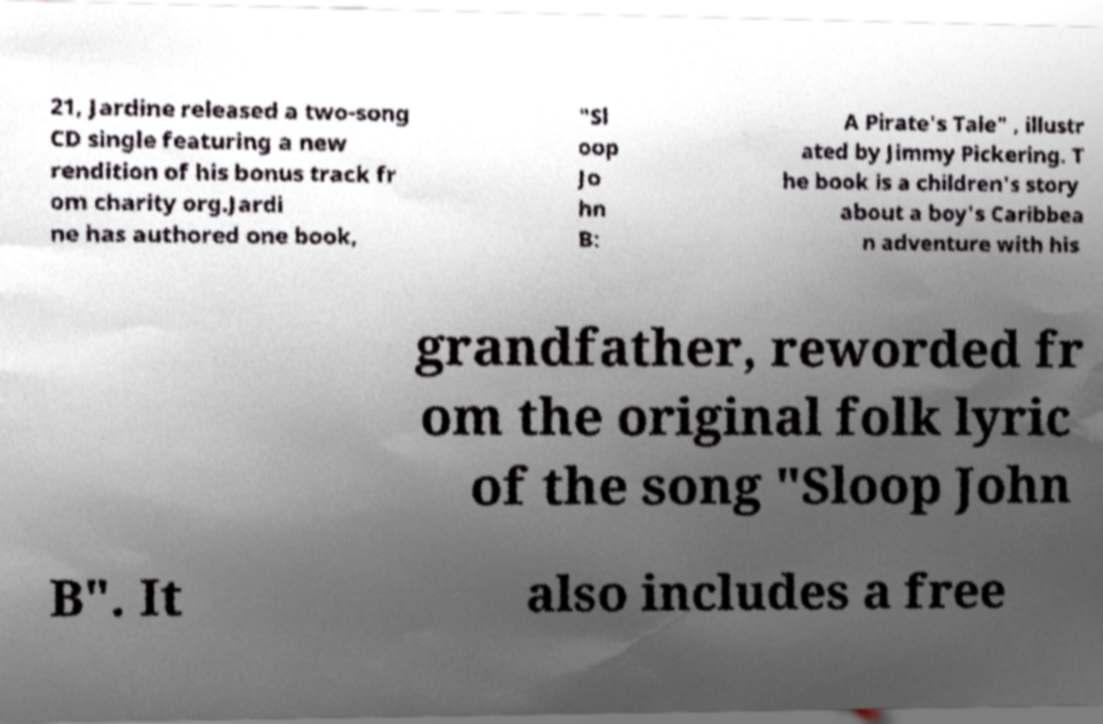Can you accurately transcribe the text from the provided image for me? 21, Jardine released a two-song CD single featuring a new rendition of his bonus track fr om charity org.Jardi ne has authored one book, "Sl oop Jo hn B: A Pirate's Tale" , illustr ated by Jimmy Pickering. T he book is a children's story about a boy's Caribbea n adventure with his grandfather, reworded fr om the original folk lyric of the song "Sloop John B". It also includes a free 